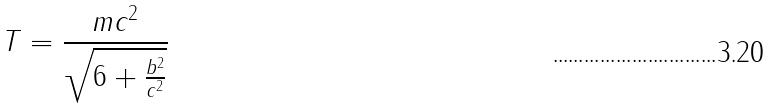Convert formula to latex. <formula><loc_0><loc_0><loc_500><loc_500>T = \frac { m c ^ { 2 } } { \sqrt { 6 + \frac { b ^ { 2 } } { c ^ { 2 } } } }</formula> 